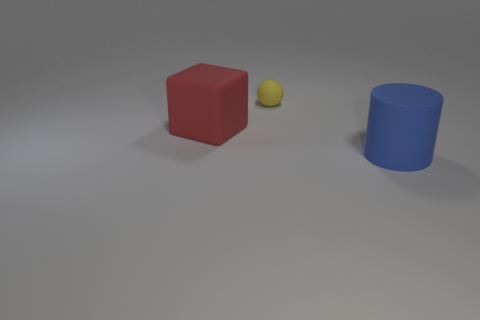There is a matte thing that is behind the red matte object in front of the small yellow object on the right side of the red object; what is its size?
Your answer should be compact. Small. There is a thing that is both in front of the ball and left of the big cylinder; what color is it?
Offer a very short reply. Red. What size is the matte thing in front of the big red rubber thing?
Make the answer very short. Large. What number of other objects have the same material as the large red object?
Give a very brief answer. 2. There is a small sphere that is the same material as the big cylinder; what is its color?
Give a very brief answer. Yellow. Is there a matte thing that is behind the matte thing that is in front of the big object on the left side of the matte cylinder?
Give a very brief answer. Yes. There is a small matte thing; what shape is it?
Make the answer very short. Sphere. Are there fewer balls to the right of the yellow rubber sphere than big purple spheres?
Keep it short and to the point. No. The rubber object that is the same size as the cylinder is what shape?
Keep it short and to the point. Cube. What number of things are either small yellow rubber balls or tiny brown matte balls?
Provide a succinct answer. 1. 